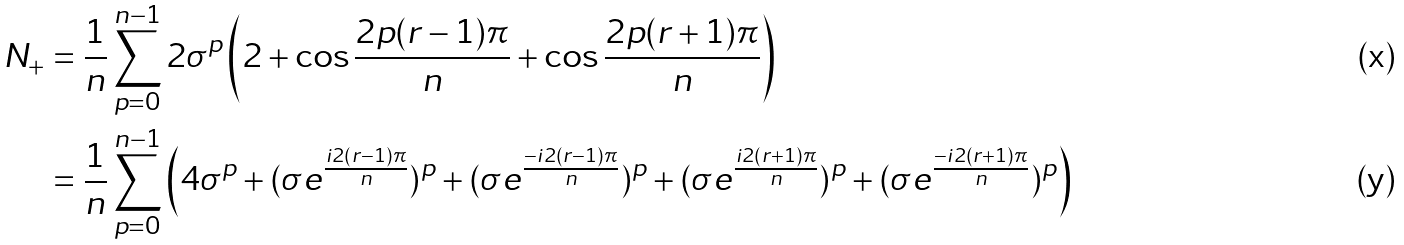<formula> <loc_0><loc_0><loc_500><loc_500>N _ { + } & = \frac { 1 } { n } \sum _ { p = 0 } ^ { n - 1 } 2 \sigma ^ { p } \left ( 2 + \cos \frac { 2 p ( r - 1 ) \pi } { n } + \cos \frac { 2 p ( r + 1 ) \pi } { n } \right ) \\ & = \frac { 1 } { n } \sum _ { p = 0 } ^ { n - 1 } \left ( 4 \sigma ^ { p } + ( \sigma e ^ { \frac { i 2 ( r - 1 ) \pi } { n } } ) ^ { p } + ( \sigma e ^ { \frac { - i 2 ( r - 1 ) \pi } { n } } ) ^ { p } + ( \sigma e ^ { \frac { i 2 ( r + 1 ) \pi } { n } } ) ^ { p } + ( \sigma e ^ { \frac { - i 2 ( r + 1 ) \pi } { n } } ) ^ { p } \right )</formula> 